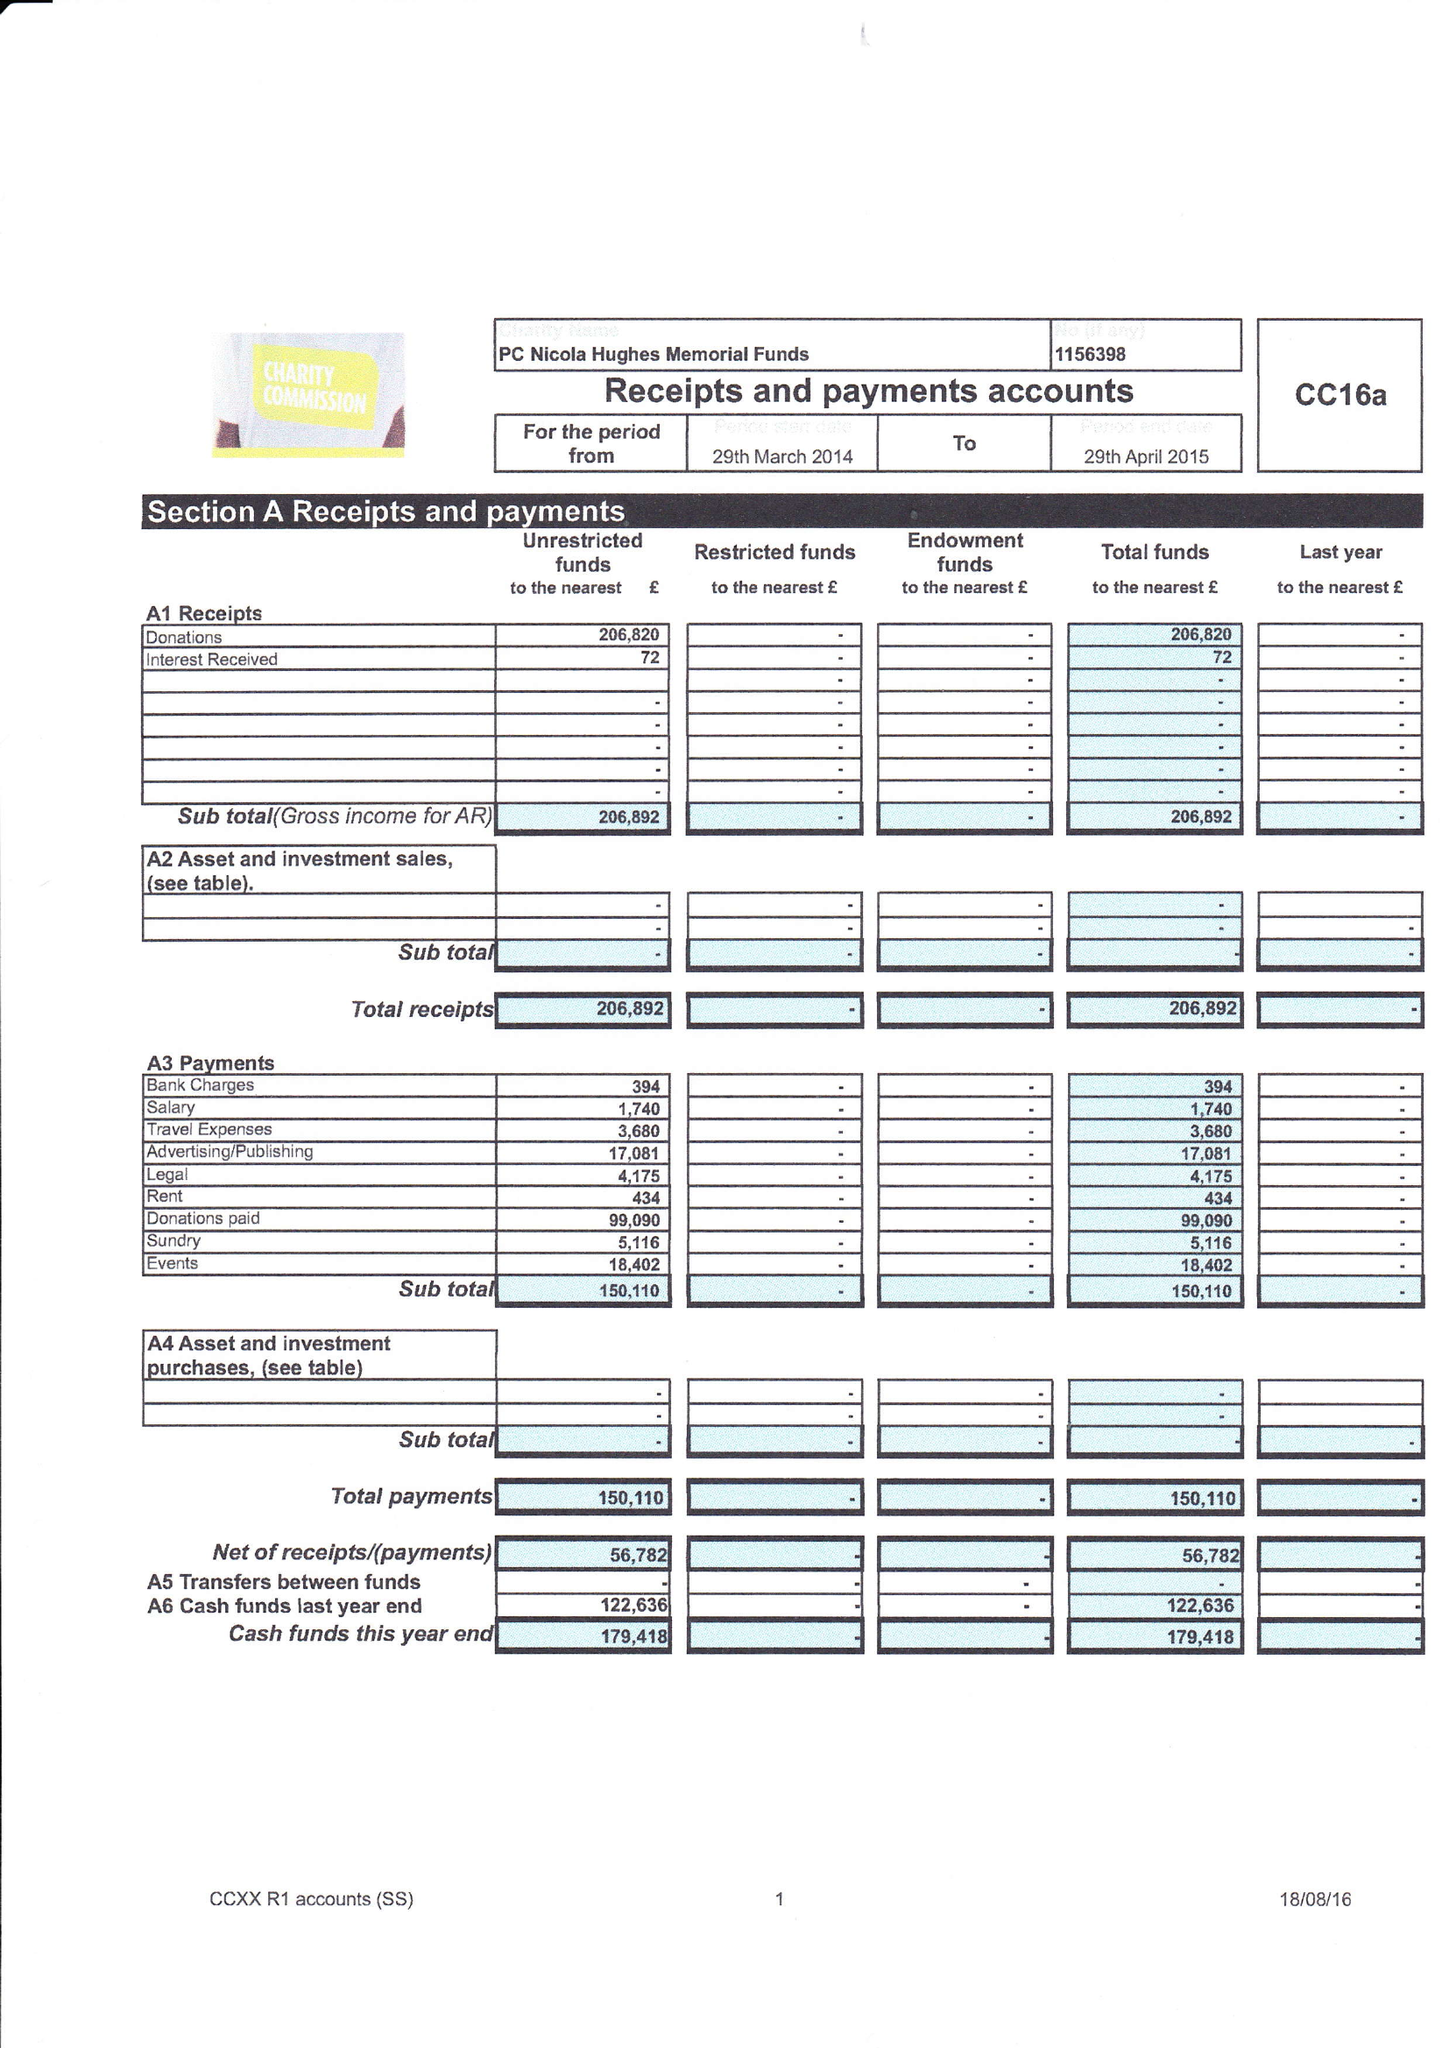What is the value for the address__street_line?
Answer the question using a single word or phrase. DELPH NEW ROAD 